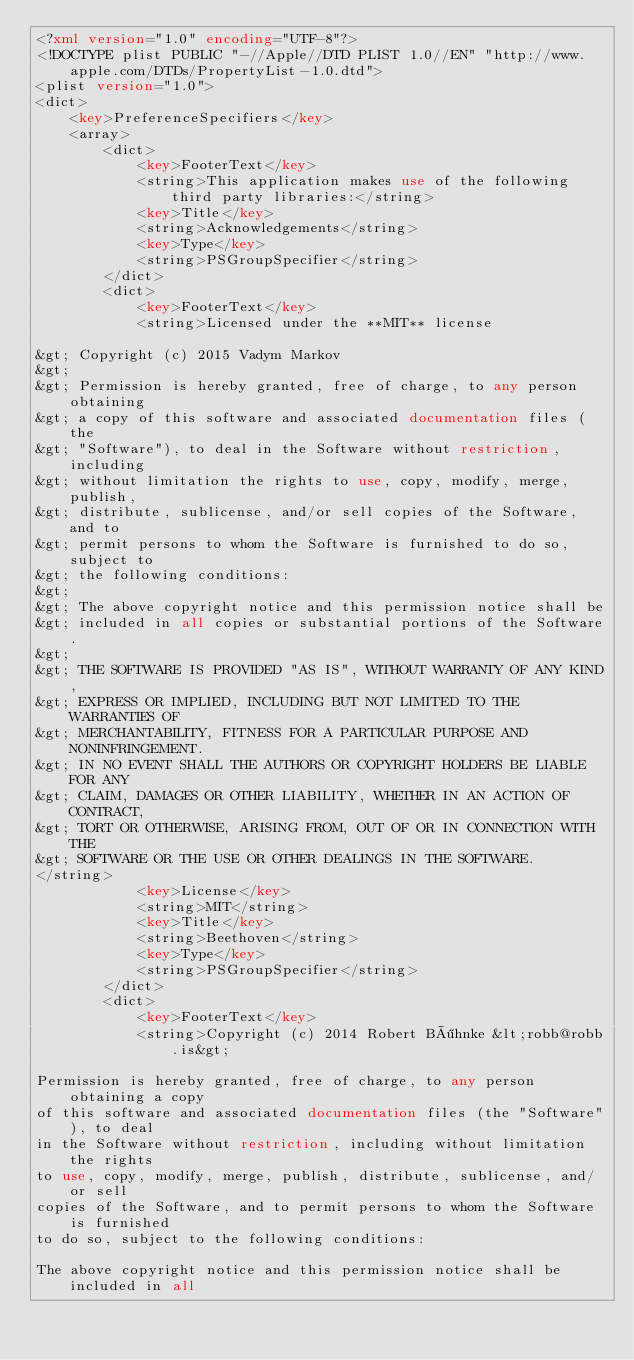Convert code to text. <code><loc_0><loc_0><loc_500><loc_500><_XML_><?xml version="1.0" encoding="UTF-8"?>
<!DOCTYPE plist PUBLIC "-//Apple//DTD PLIST 1.0//EN" "http://www.apple.com/DTDs/PropertyList-1.0.dtd">
<plist version="1.0">
<dict>
	<key>PreferenceSpecifiers</key>
	<array>
		<dict>
			<key>FooterText</key>
			<string>This application makes use of the following third party libraries:</string>
			<key>Title</key>
			<string>Acknowledgements</string>
			<key>Type</key>
			<string>PSGroupSpecifier</string>
		</dict>
		<dict>
			<key>FooterText</key>
			<string>Licensed under the **MIT** license

&gt; Copyright (c) 2015 Vadym Markov
&gt;
&gt; Permission is hereby granted, free of charge, to any person obtaining
&gt; a copy of this software and associated documentation files (the
&gt; "Software"), to deal in the Software without restriction, including
&gt; without limitation the rights to use, copy, modify, merge, publish,
&gt; distribute, sublicense, and/or sell copies of the Software, and to
&gt; permit persons to whom the Software is furnished to do so, subject to
&gt; the following conditions:
&gt;
&gt; The above copyright notice and this permission notice shall be
&gt; included in all copies or substantial portions of the Software.
&gt;
&gt; THE SOFTWARE IS PROVIDED "AS IS", WITHOUT WARRANTY OF ANY KIND,
&gt; EXPRESS OR IMPLIED, INCLUDING BUT NOT LIMITED TO THE WARRANTIES OF
&gt; MERCHANTABILITY, FITNESS FOR A PARTICULAR PURPOSE AND NONINFRINGEMENT.
&gt; IN NO EVENT SHALL THE AUTHORS OR COPYRIGHT HOLDERS BE LIABLE FOR ANY
&gt; CLAIM, DAMAGES OR OTHER LIABILITY, WHETHER IN AN ACTION OF CONTRACT,
&gt; TORT OR OTHERWISE, ARISING FROM, OUT OF OR IN CONNECTION WITH THE
&gt; SOFTWARE OR THE USE OR OTHER DEALINGS IN THE SOFTWARE.
</string>
			<key>License</key>
			<string>MIT</string>
			<key>Title</key>
			<string>Beethoven</string>
			<key>Type</key>
			<string>PSGroupSpecifier</string>
		</dict>
		<dict>
			<key>FooterText</key>
			<string>Copyright (c) 2014 Robert Böhnke &lt;robb@robb.is&gt;

Permission is hereby granted, free of charge, to any person obtaining a copy
of this software and associated documentation files (the "Software"), to deal
in the Software without restriction, including without limitation the rights
to use, copy, modify, merge, publish, distribute, sublicense, and/or sell
copies of the Software, and to permit persons to whom the Software is furnished
to do so, subject to the following conditions:

The above copyright notice and this permission notice shall be included in all</code> 